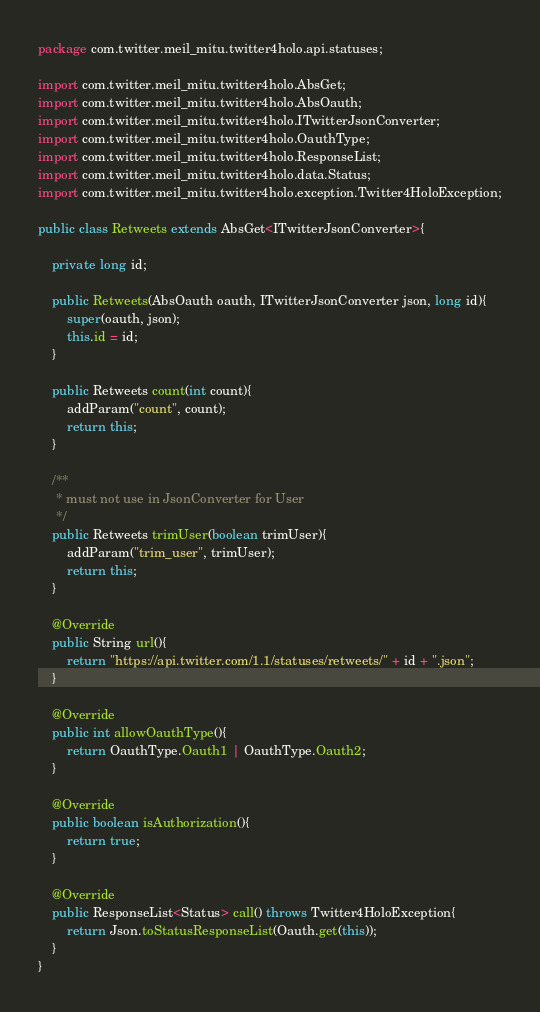<code> <loc_0><loc_0><loc_500><loc_500><_Java_>package com.twitter.meil_mitu.twitter4holo.api.statuses;

import com.twitter.meil_mitu.twitter4holo.AbsGet;
import com.twitter.meil_mitu.twitter4holo.AbsOauth;
import com.twitter.meil_mitu.twitter4holo.ITwitterJsonConverter;
import com.twitter.meil_mitu.twitter4holo.OauthType;
import com.twitter.meil_mitu.twitter4holo.ResponseList;
import com.twitter.meil_mitu.twitter4holo.data.Status;
import com.twitter.meil_mitu.twitter4holo.exception.Twitter4HoloException;

public class Retweets extends AbsGet<ITwitterJsonConverter>{

    private long id;

    public Retweets(AbsOauth oauth, ITwitterJsonConverter json, long id){
        super(oauth, json);
        this.id = id;
    }

    public Retweets count(int count){
        addParam("count", count);
        return this;
    }

    /**
     * must not use in JsonConverter for User
     */
    public Retweets trimUser(boolean trimUser){
        addParam("trim_user", trimUser);
        return this;
    }

    @Override
    public String url(){
        return "https://api.twitter.com/1.1/statuses/retweets/" + id + ".json";
    }

    @Override
    public int allowOauthType(){
        return OauthType.Oauth1 | OauthType.Oauth2;
    }

    @Override
    public boolean isAuthorization(){
        return true;
    }

    @Override
    public ResponseList<Status> call() throws Twitter4HoloException{
        return Json.toStatusResponseList(Oauth.get(this));
    }
}
</code> 